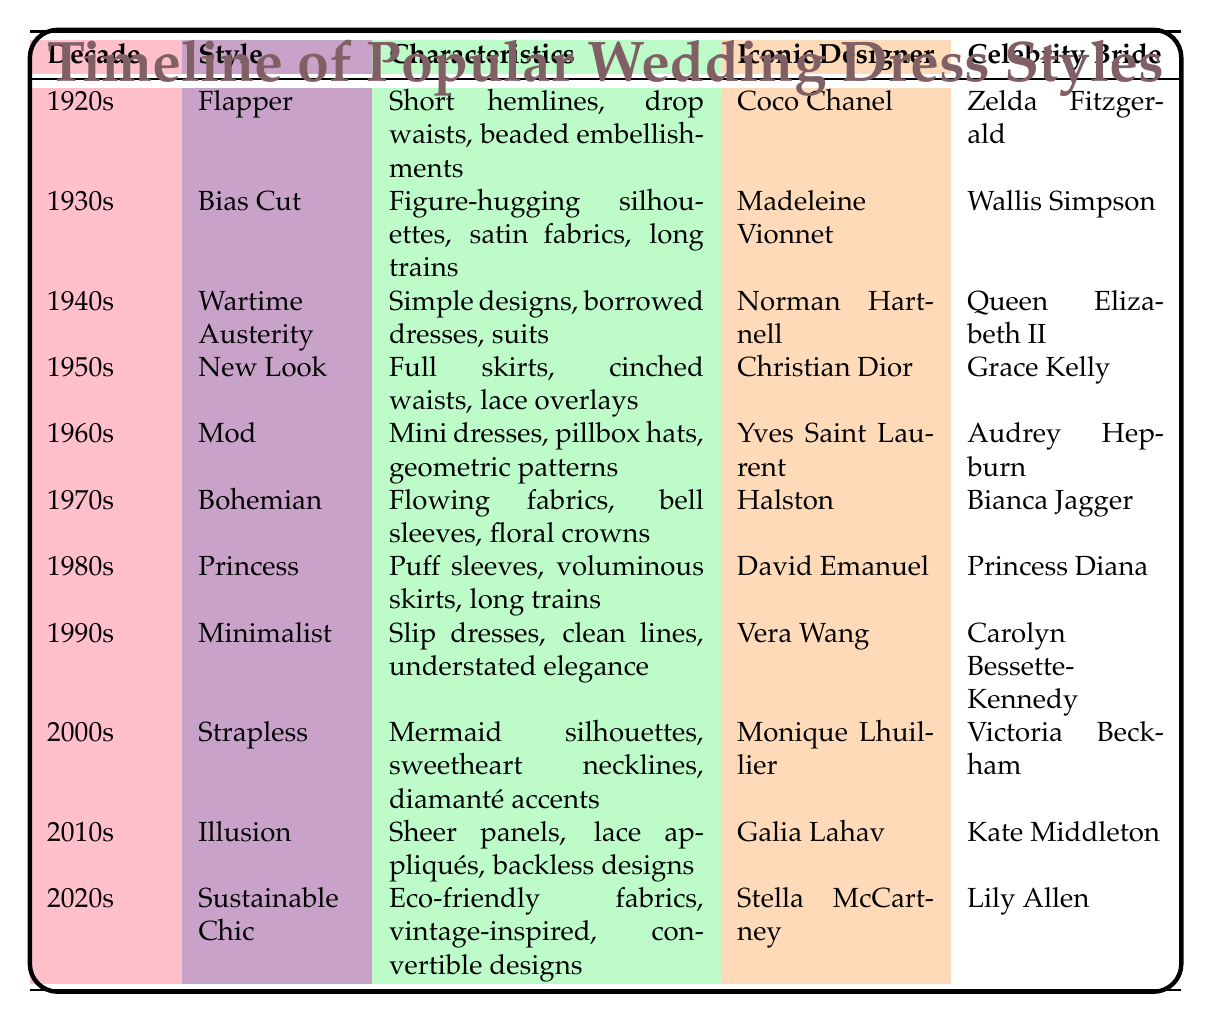What wedding dress style is associated with Grace Kelly? Grace Kelly is listed in the row for the 1950s, where the style is "New Look".
Answer: New Look Which iconic designer created the "Princess" style in the 1980s? The table indicates that the style "Princess" was designed by David Emanuel during the 1980s.
Answer: David Emanuel In which decade did the "Mod" style appear? The "Mod" style is recorded in the table under the 1960s.
Answer: 1960s How many celebrity brides are associated with dresses that have flowing fabrics? The "Bohemian" style from the 1970s has Alice Jagger, and the "Illusion" style from the 2010s does not mention flowing fabrics. Therefore, only one celebrity bride is associated with the "Bohemian" style.
Answer: 1 Was the "Strapless" style more popular in the 2000s or the 1990s? The "Strapless" style is from the 2000s and does not appear in the 1990s section. Thus, it is more popular during the 2000s.
Answer: Yes What are the characteristics of the wedding dress style from the 1940s? The 1940s style is "Wartime Austerity", with characteristics including simple designs and borrowed dresses.
Answer: Simple designs, borrowed dresses, suits Which dress style has the most iconic designer mentioned in the list? The "Wartime Austerity" style from the 1940s is associated with Norman Hartnell, which is a significant name in fashion history, but all styles have their iconic designers. This may require subjective judgment, but Norman Hartnell is highly recognized.
Answer: Wartime Austerity How does the "Sustainable Chic" style of the 2020s compare to the "Flapper" style of the 1920s in terms of their characteristics? "Sustainable Chic" includes eco-friendly fabrics and convertible designs, while "Flapper" features short hemlines and beaded embellishments. They reflect different values of sustainability versus the lavishness of the 1920s.
Answer: Different values What decade introduced the "Minimalist" style, and what are its key characteristics? The "Minimalist" style appeared in the 1990s, characterized by slip dresses, clean lines, and understated elegance.
Answer: 1990s: slip dresses, clean lines, understated elegance 